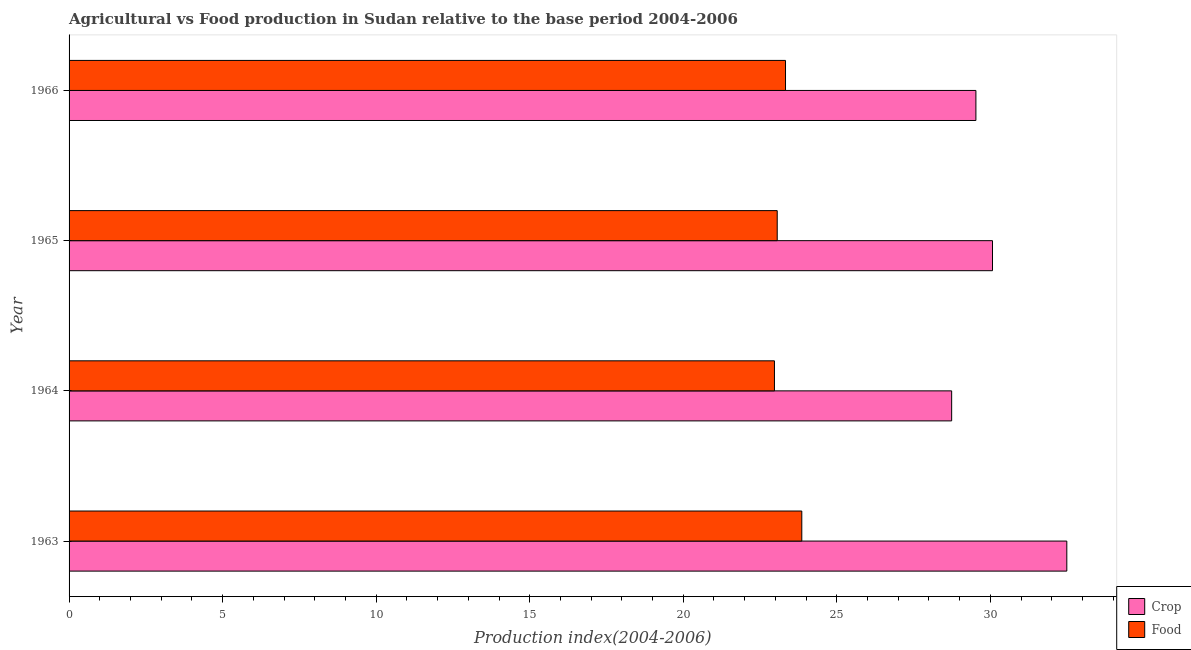How many different coloured bars are there?
Offer a very short reply. 2. Are the number of bars per tick equal to the number of legend labels?
Make the answer very short. Yes. Are the number of bars on each tick of the Y-axis equal?
Provide a succinct answer. Yes. What is the label of the 4th group of bars from the top?
Your answer should be very brief. 1963. What is the crop production index in 1963?
Offer a very short reply. 32.49. Across all years, what is the maximum food production index?
Offer a very short reply. 23.86. Across all years, what is the minimum food production index?
Your answer should be compact. 22.97. In which year was the crop production index maximum?
Give a very brief answer. 1963. In which year was the food production index minimum?
Provide a short and direct response. 1964. What is the total food production index in the graph?
Your response must be concise. 93.22. What is the difference between the food production index in 1964 and that in 1965?
Your response must be concise. -0.09. What is the difference between the food production index in 1963 and the crop production index in 1965?
Provide a short and direct response. -6.21. What is the average crop production index per year?
Your answer should be very brief. 30.21. In the year 1965, what is the difference between the crop production index and food production index?
Keep it short and to the point. 7.01. In how many years, is the crop production index greater than 5 ?
Offer a terse response. 4. What is the difference between the highest and the second highest food production index?
Keep it short and to the point. 0.53. What is the difference between the highest and the lowest food production index?
Your response must be concise. 0.89. Is the sum of the crop production index in 1963 and 1966 greater than the maximum food production index across all years?
Keep it short and to the point. Yes. What does the 2nd bar from the top in 1963 represents?
Provide a short and direct response. Crop. What does the 2nd bar from the bottom in 1966 represents?
Offer a very short reply. Food. Are all the bars in the graph horizontal?
Your response must be concise. Yes. How many years are there in the graph?
Your response must be concise. 4. Where does the legend appear in the graph?
Offer a terse response. Bottom right. How many legend labels are there?
Your answer should be very brief. 2. How are the legend labels stacked?
Provide a short and direct response. Vertical. What is the title of the graph?
Your answer should be compact. Agricultural vs Food production in Sudan relative to the base period 2004-2006. Does "IMF concessional" appear as one of the legend labels in the graph?
Provide a short and direct response. No. What is the label or title of the X-axis?
Offer a terse response. Production index(2004-2006). What is the label or title of the Y-axis?
Your response must be concise. Year. What is the Production index(2004-2006) in Crop in 1963?
Offer a very short reply. 32.49. What is the Production index(2004-2006) of Food in 1963?
Your response must be concise. 23.86. What is the Production index(2004-2006) of Crop in 1964?
Keep it short and to the point. 28.74. What is the Production index(2004-2006) in Food in 1964?
Keep it short and to the point. 22.97. What is the Production index(2004-2006) of Crop in 1965?
Keep it short and to the point. 30.07. What is the Production index(2004-2006) of Food in 1965?
Keep it short and to the point. 23.06. What is the Production index(2004-2006) in Crop in 1966?
Your answer should be very brief. 29.53. What is the Production index(2004-2006) in Food in 1966?
Make the answer very short. 23.33. Across all years, what is the maximum Production index(2004-2006) in Crop?
Offer a very short reply. 32.49. Across all years, what is the maximum Production index(2004-2006) in Food?
Your answer should be compact. 23.86. Across all years, what is the minimum Production index(2004-2006) in Crop?
Your answer should be very brief. 28.74. Across all years, what is the minimum Production index(2004-2006) in Food?
Offer a very short reply. 22.97. What is the total Production index(2004-2006) in Crop in the graph?
Ensure brevity in your answer.  120.83. What is the total Production index(2004-2006) of Food in the graph?
Provide a short and direct response. 93.22. What is the difference between the Production index(2004-2006) in Crop in 1963 and that in 1964?
Offer a terse response. 3.75. What is the difference between the Production index(2004-2006) in Food in 1963 and that in 1964?
Your answer should be very brief. 0.89. What is the difference between the Production index(2004-2006) in Crop in 1963 and that in 1965?
Offer a terse response. 2.42. What is the difference between the Production index(2004-2006) of Crop in 1963 and that in 1966?
Offer a very short reply. 2.96. What is the difference between the Production index(2004-2006) of Food in 1963 and that in 1966?
Make the answer very short. 0.53. What is the difference between the Production index(2004-2006) of Crop in 1964 and that in 1965?
Offer a terse response. -1.33. What is the difference between the Production index(2004-2006) of Food in 1964 and that in 1965?
Give a very brief answer. -0.09. What is the difference between the Production index(2004-2006) in Crop in 1964 and that in 1966?
Give a very brief answer. -0.79. What is the difference between the Production index(2004-2006) of Food in 1964 and that in 1966?
Give a very brief answer. -0.36. What is the difference between the Production index(2004-2006) of Crop in 1965 and that in 1966?
Ensure brevity in your answer.  0.54. What is the difference between the Production index(2004-2006) of Food in 1965 and that in 1966?
Offer a very short reply. -0.27. What is the difference between the Production index(2004-2006) of Crop in 1963 and the Production index(2004-2006) of Food in 1964?
Give a very brief answer. 9.52. What is the difference between the Production index(2004-2006) of Crop in 1963 and the Production index(2004-2006) of Food in 1965?
Provide a succinct answer. 9.43. What is the difference between the Production index(2004-2006) of Crop in 1963 and the Production index(2004-2006) of Food in 1966?
Keep it short and to the point. 9.16. What is the difference between the Production index(2004-2006) of Crop in 1964 and the Production index(2004-2006) of Food in 1965?
Your answer should be very brief. 5.68. What is the difference between the Production index(2004-2006) of Crop in 1964 and the Production index(2004-2006) of Food in 1966?
Keep it short and to the point. 5.41. What is the difference between the Production index(2004-2006) in Crop in 1965 and the Production index(2004-2006) in Food in 1966?
Ensure brevity in your answer.  6.74. What is the average Production index(2004-2006) in Crop per year?
Your answer should be compact. 30.21. What is the average Production index(2004-2006) of Food per year?
Give a very brief answer. 23.3. In the year 1963, what is the difference between the Production index(2004-2006) of Crop and Production index(2004-2006) of Food?
Make the answer very short. 8.63. In the year 1964, what is the difference between the Production index(2004-2006) in Crop and Production index(2004-2006) in Food?
Your answer should be compact. 5.77. In the year 1965, what is the difference between the Production index(2004-2006) in Crop and Production index(2004-2006) in Food?
Your answer should be very brief. 7.01. In the year 1966, what is the difference between the Production index(2004-2006) in Crop and Production index(2004-2006) in Food?
Your answer should be compact. 6.2. What is the ratio of the Production index(2004-2006) of Crop in 1963 to that in 1964?
Your answer should be compact. 1.13. What is the ratio of the Production index(2004-2006) in Food in 1963 to that in 1964?
Your answer should be very brief. 1.04. What is the ratio of the Production index(2004-2006) of Crop in 1963 to that in 1965?
Provide a succinct answer. 1.08. What is the ratio of the Production index(2004-2006) of Food in 1963 to that in 1965?
Your answer should be compact. 1.03. What is the ratio of the Production index(2004-2006) in Crop in 1963 to that in 1966?
Provide a succinct answer. 1.1. What is the ratio of the Production index(2004-2006) of Food in 1963 to that in 1966?
Offer a very short reply. 1.02. What is the ratio of the Production index(2004-2006) of Crop in 1964 to that in 1965?
Your answer should be very brief. 0.96. What is the ratio of the Production index(2004-2006) in Food in 1964 to that in 1965?
Keep it short and to the point. 1. What is the ratio of the Production index(2004-2006) in Crop in 1964 to that in 1966?
Keep it short and to the point. 0.97. What is the ratio of the Production index(2004-2006) of Food in 1964 to that in 1966?
Keep it short and to the point. 0.98. What is the ratio of the Production index(2004-2006) in Crop in 1965 to that in 1966?
Your response must be concise. 1.02. What is the ratio of the Production index(2004-2006) of Food in 1965 to that in 1966?
Offer a very short reply. 0.99. What is the difference between the highest and the second highest Production index(2004-2006) of Crop?
Offer a very short reply. 2.42. What is the difference between the highest and the second highest Production index(2004-2006) in Food?
Your response must be concise. 0.53. What is the difference between the highest and the lowest Production index(2004-2006) in Crop?
Offer a very short reply. 3.75. What is the difference between the highest and the lowest Production index(2004-2006) in Food?
Provide a short and direct response. 0.89. 